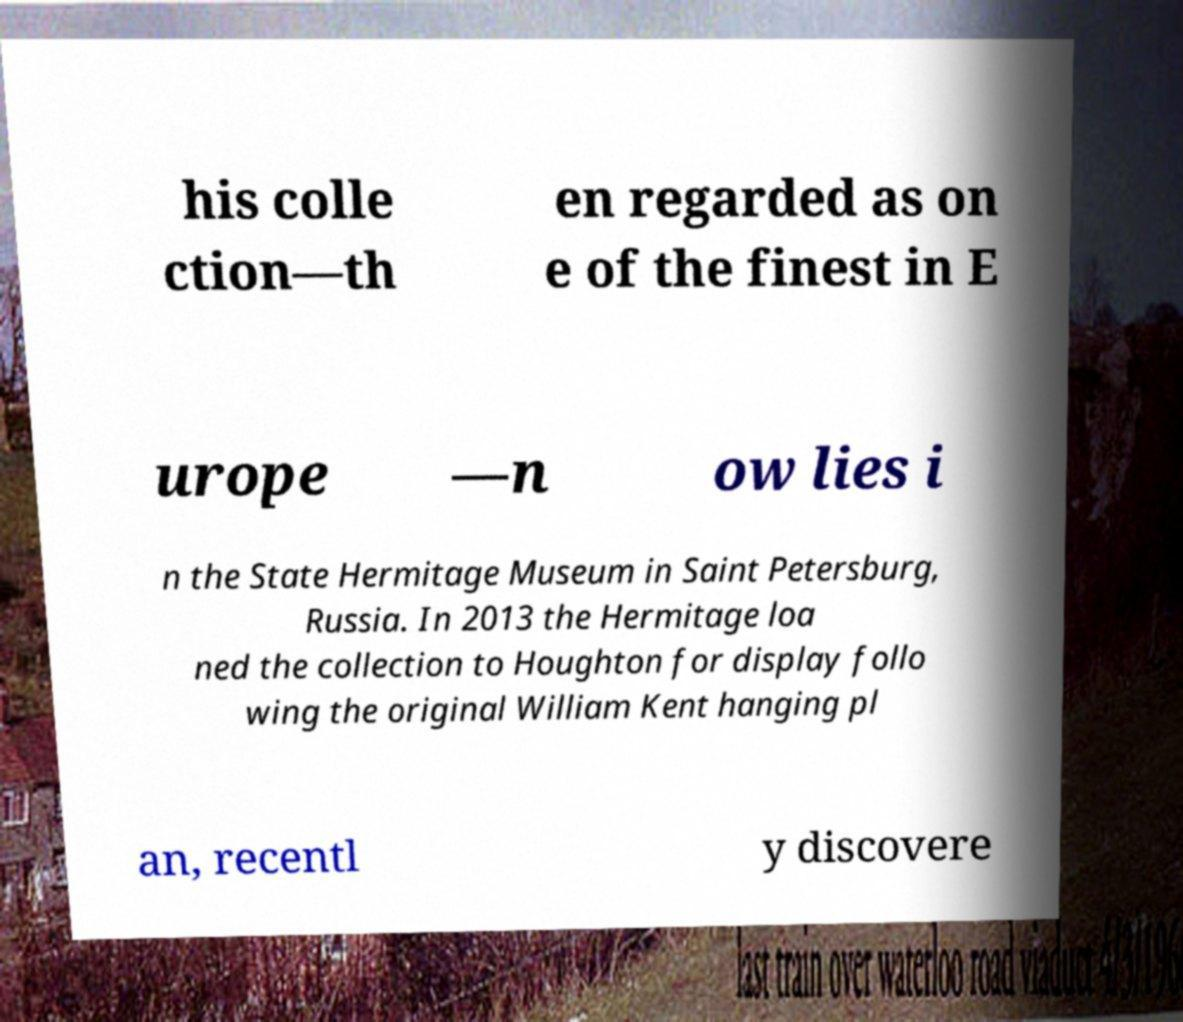Could you assist in decoding the text presented in this image and type it out clearly? his colle ction—th en regarded as on e of the finest in E urope —n ow lies i n the State Hermitage Museum in Saint Petersburg, Russia. In 2013 the Hermitage loa ned the collection to Houghton for display follo wing the original William Kent hanging pl an, recentl y discovere 